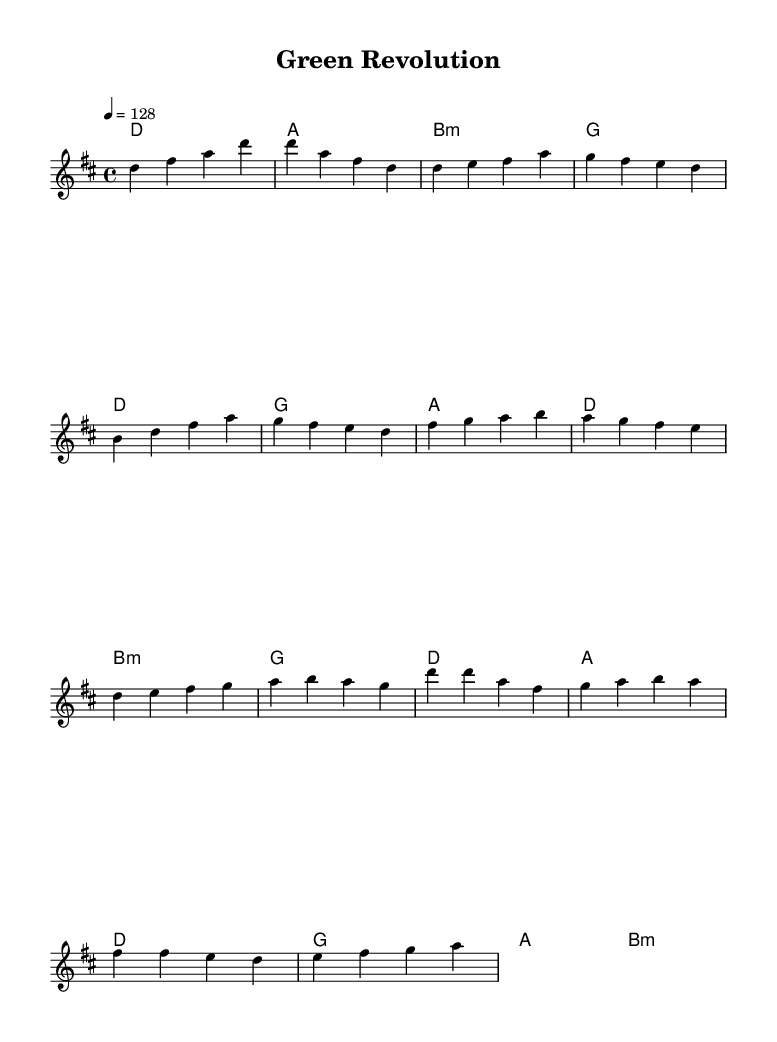What is the key signature of this music? The key signature indicates D major, which has two sharps: F# and C#. This can be identified by looking at the key signature at the beginning of the staff.
Answer: D major What is the time signature of this music? The time signature is 4/4, which means there are four beats in each measure, and each quarter note gets one beat. This is typically indicated at the beginning of the piece.
Answer: 4/4 What is the tempo marking for this piece? The tempo marking indicates a speed of 128 beats per minute (bpm). This is noted as "4 = 128" where "4" represents the quarter note.
Answer: 128 How many measures are there in the chorus section? By examining the notation, the chorus consists of four measures, as indicated by the vertical bar lines separating each measure.
Answer: Four Which chord is used in the pre-chorus? The pre-chorus section includes the B minor chord, which is indicated in the chord changes. This can be confirmed while reviewing the chord progression during that section of the music.
Answer: B minor What is the highest note in the melody? The highest note in the melody is D. This is determined by scanning through the notes in the melody line and identifying that D, located at the top of the staff, is the peak.
Answer: D What musical genre does this piece represent? The piece is categorized as K-Pop due to its energetic style, upbeat tempo, and danceable rhythm, characteristics that define the genre as seen in the music and its purpose.
Answer: K-Pop 